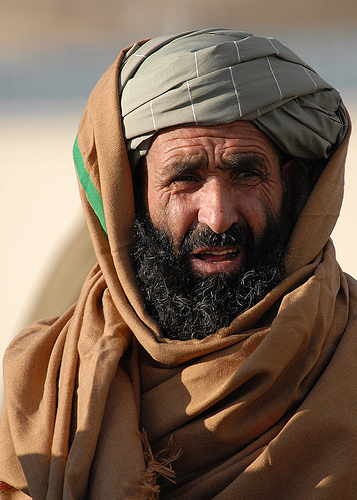<image>
Is the america under the beard? No. The america is not positioned under the beard. The vertical relationship between these objects is different. 